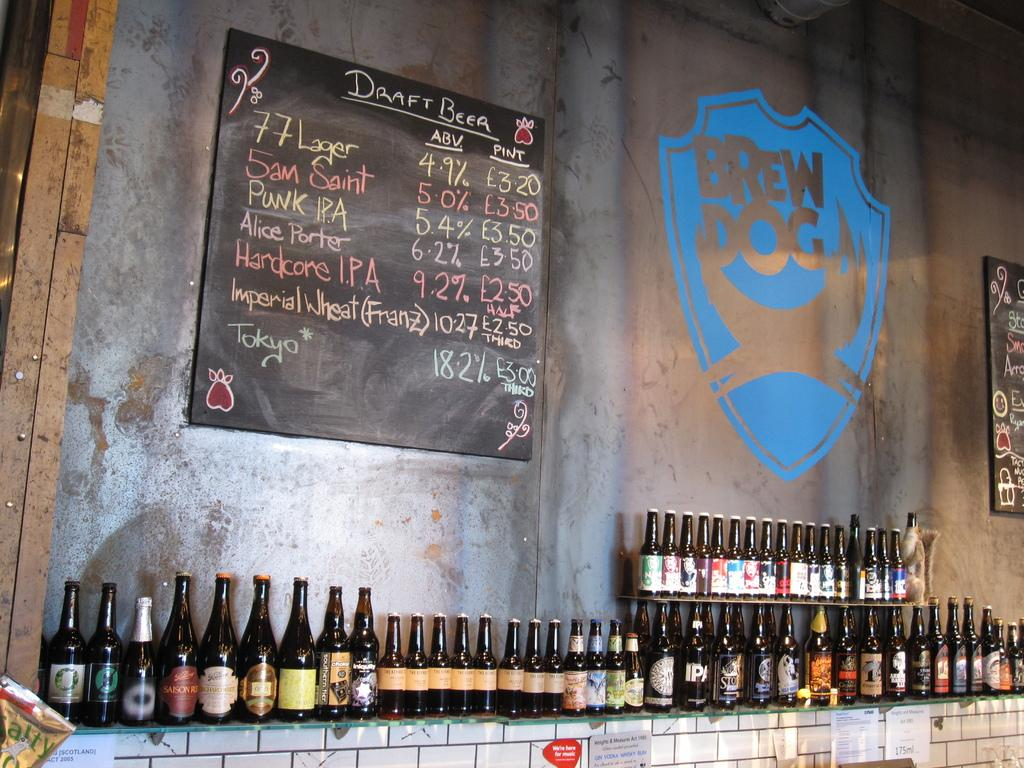What type of bottles are visible in the image? There are alcohol bottles in the image. How are the bottles arranged in the image? The bottles are placed in a row. What can be seen in the background of the image? There is a wall and a blackboard in the background of the image. What is written on the blackboard? There is handwritten text on the blackboard. What type of operation is being performed on the bottles in the image? There is no operation being performed on the bottles in the image; they are simply placed in a row. 